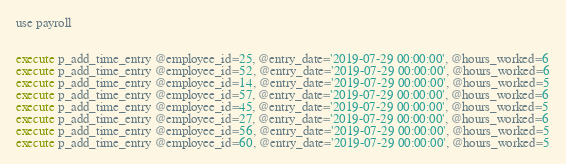Convert code to text. <code><loc_0><loc_0><loc_500><loc_500><_SQL_>use payroll


execute p_add_time_entry @employee_id=25, @entry_date='2019-07-29 00:00:00', @hours_worked=6
execute p_add_time_entry @employee_id=52, @entry_date='2019-07-29 00:00:00', @hours_worked=6
execute p_add_time_entry @employee_id=14, @entry_date='2019-07-29 00:00:00', @hours_worked=5
execute p_add_time_entry @employee_id=57, @entry_date='2019-07-29 00:00:00', @hours_worked=6
execute p_add_time_entry @employee_id=45, @entry_date='2019-07-29 00:00:00', @hours_worked=5
execute p_add_time_entry @employee_id=27, @entry_date='2019-07-29 00:00:00', @hours_worked=6
execute p_add_time_entry @employee_id=56, @entry_date='2019-07-29 00:00:00', @hours_worked=5
execute p_add_time_entry @employee_id=60, @entry_date='2019-07-29 00:00:00', @hours_worked=5

</code> 